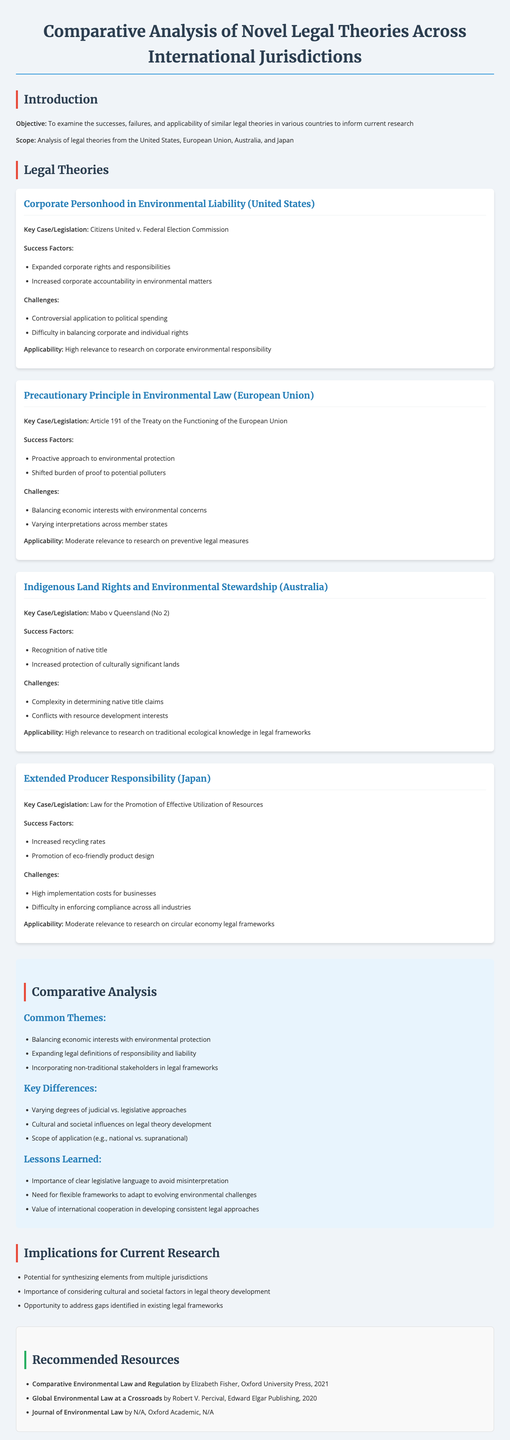What is the title of the report? The title of the report is mentioned in the introduction section.
Answer: Comparative Analysis of Novel Legal Theories Across International Jurisdictions Which jurisdiction discusses the "Precautionary Principle in Environmental Law"? The jurisdiction is specified alongside the legal theory in the document.
Answer: European Union What is a key case associated with Indigenous Land Rights in Australia? The key case is mentioned under the legal theory section for Australia.
Answer: Mabo v Queensland (No 2) What is one success factor of Corporate Personhood in Environmental Liability? The success factors are listed for each legal theory.
Answer: Increased corporate accountability in environmental matters What are the common themes identified in the comparative analysis? The document lists common themes that emerged from the analysis.
Answer: Balancing economic interests with environmental protection What challenges does Extended Producer Responsibility face in Japan? The challenges are specified in relation to the legal theory discussed.
Answer: High implementation costs for businesses How many legal theories were analyzed in the report? The number of legal theories is indicated in the document.
Answer: Four What is one implication for current research outlined in the document? Implications for research are directly listed in the implications section.
Answer: Importance of considering cultural and societal factors in legal theory development Who is the author of the recommended resource titled "Global Environmental Law at a Crossroads"? The author's name is mentioned alongside the resource information.
Answer: Robert V. Percival 